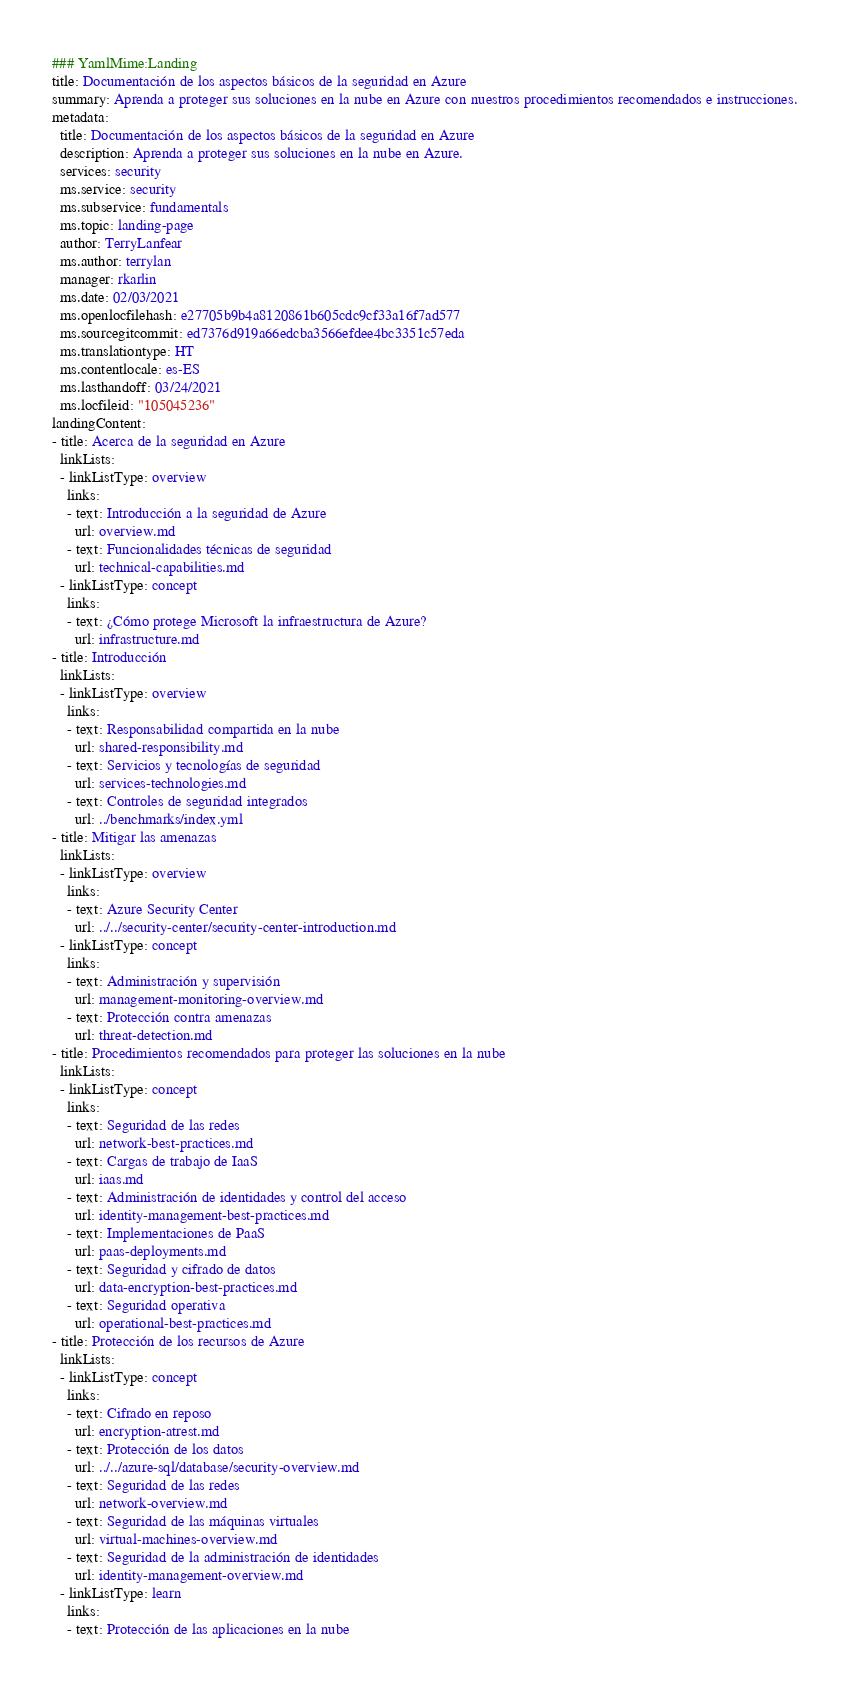Convert code to text. <code><loc_0><loc_0><loc_500><loc_500><_YAML_>### YamlMime:Landing
title: Documentación de los aspectos básicos de la seguridad en Azure
summary: Aprenda a proteger sus soluciones en la nube en Azure con nuestros procedimientos recomendados e instrucciones.
metadata:
  title: Documentación de los aspectos básicos de la seguridad en Azure
  description: Aprenda a proteger sus soluciones en la nube en Azure.
  services: security
  ms.service: security
  ms.subservice: fundamentals
  ms.topic: landing-page
  author: TerryLanfear
  ms.author: terrylan
  manager: rkarlin
  ms.date: 02/03/2021
  ms.openlocfilehash: e27705b9b4a8120861b605cdc9cf33a16f7ad577
  ms.sourcegitcommit: ed7376d919a66edcba3566efdee4bc3351c57eda
  ms.translationtype: HT
  ms.contentlocale: es-ES
  ms.lasthandoff: 03/24/2021
  ms.locfileid: "105045236"
landingContent:
- title: Acerca de la seguridad en Azure
  linkLists:
  - linkListType: overview
    links:
    - text: Introducción a la seguridad de Azure
      url: overview.md
    - text: Funcionalidades técnicas de seguridad
      url: technical-capabilities.md
  - linkListType: concept
    links:
    - text: ¿Cómo protege Microsoft la infraestructura de Azure?
      url: infrastructure.md
- title: Introducción
  linkLists:
  - linkListType: overview
    links:
    - text: Responsabilidad compartida en la nube
      url: shared-responsibility.md
    - text: Servicios y tecnologías de seguridad
      url: services-technologies.md
    - text: Controles de seguridad integrados
      url: ../benchmarks/index.yml
- title: Mitigar las amenazas
  linkLists:
  - linkListType: overview
    links:
    - text: Azure Security Center
      url: ../../security-center/security-center-introduction.md
  - linkListType: concept
    links:
    - text: Administración y supervisión
      url: management-monitoring-overview.md
    - text: Protección contra amenazas
      url: threat-detection.md
- title: Procedimientos recomendados para proteger las soluciones en la nube
  linkLists:
  - linkListType: concept
    links:
    - text: Seguridad de las redes
      url: network-best-practices.md
    - text: Cargas de trabajo de IaaS
      url: iaas.md
    - text: Administración de identidades y control del acceso
      url: identity-management-best-practices.md
    - text: Implementaciones de PaaS
      url: paas-deployments.md
    - text: Seguridad y cifrado de datos
      url: data-encryption-best-practices.md
    - text: Seguridad operativa
      url: operational-best-practices.md
- title: Protección de los recursos de Azure
  linkLists:
  - linkListType: concept
    links:
    - text: Cifrado en reposo
      url: encryption-atrest.md
    - text: Protección de los datos
      url: ../../azure-sql/database/security-overview.md
    - text: Seguridad de las redes
      url: network-overview.md
    - text: Seguridad de las máquinas virtuales
      url: virtual-machines-overview.md
    - text: Seguridad de la administración de identidades
      url: identity-management-overview.md
  - linkListType: learn
    links:
    - text: Protección de las aplicaciones en la nube</code> 